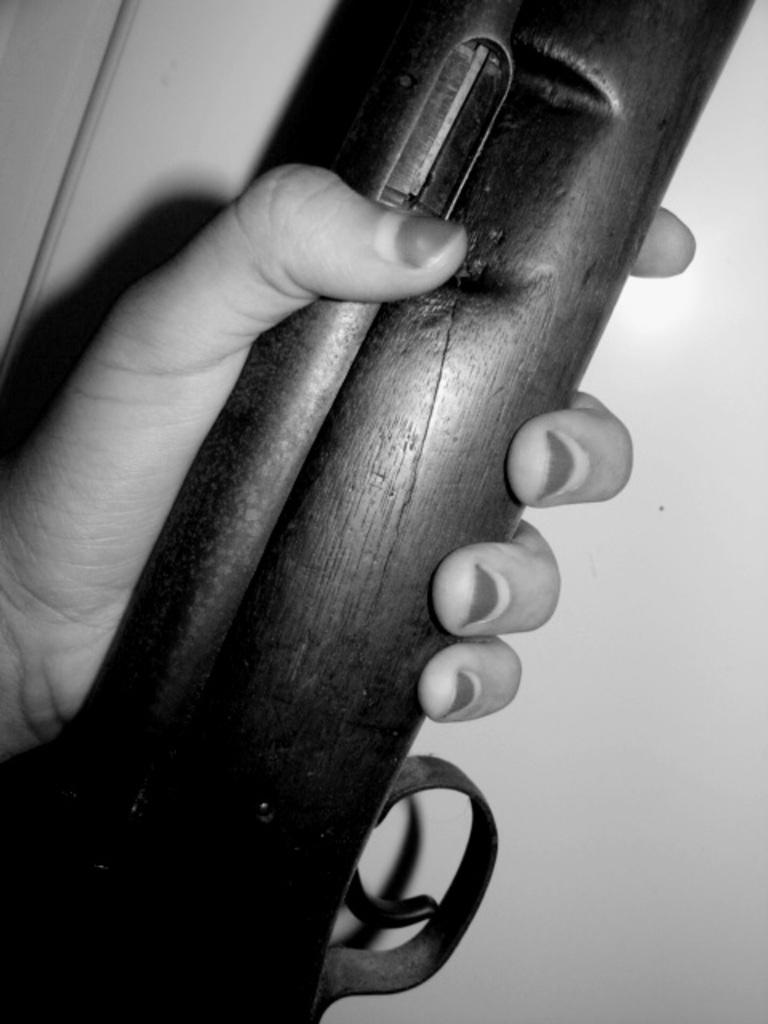What can be seen in the image that belongs to a person? There is a person's hand in the image. What is the person holding in the image? The person is holding a gun. What can be seen in the background of the image? There is a wall in the background of the image. What type of sea creature can be seen swimming in the image? There is no sea creature present in the image; it features a person's hand holding a gun with a wall in the background. 